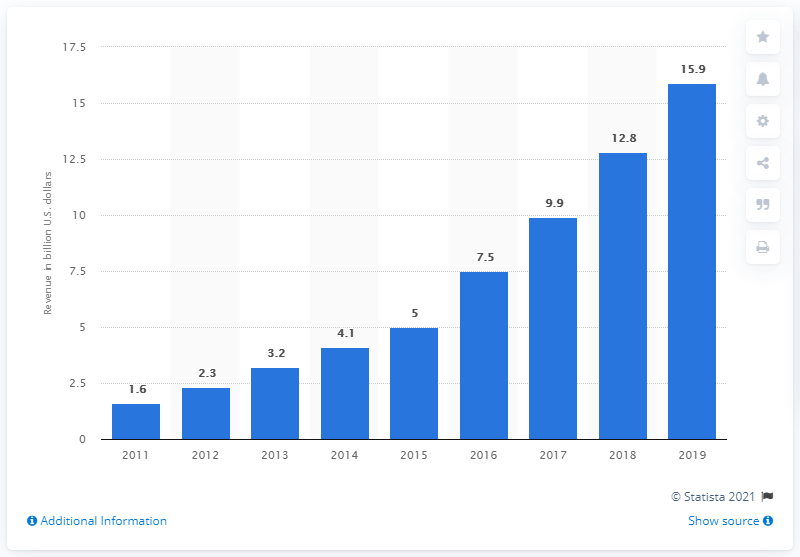Give some essential details in this illustration. In 2019, the revenue generated from subscription video on demand (SVoD) in the United States was approximately 15.9 billion U.S. dollars. 